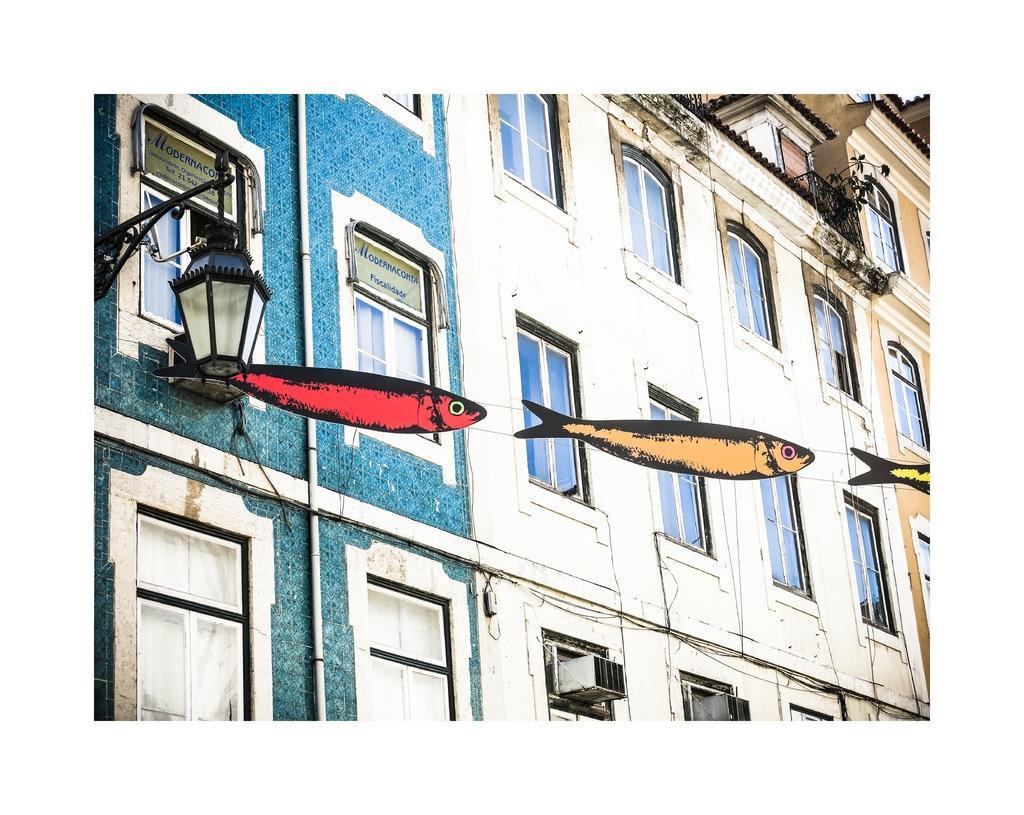Could you give a brief overview of what you see in this image? In this image, we can see some buildings. We can also see a light and some boards with text. We can also see some objects attached to the rope. 